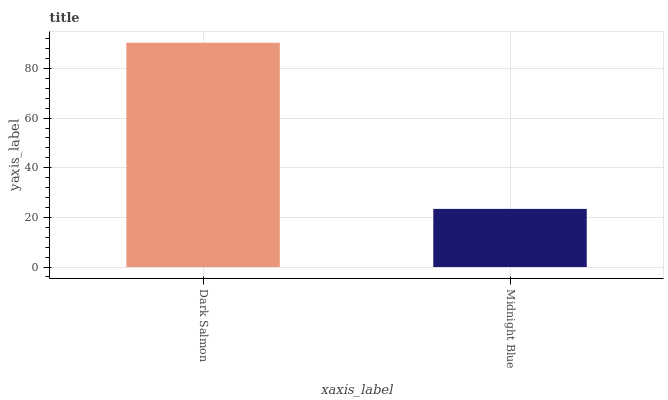Is Midnight Blue the minimum?
Answer yes or no. Yes. Is Dark Salmon the maximum?
Answer yes or no. Yes. Is Midnight Blue the maximum?
Answer yes or no. No. Is Dark Salmon greater than Midnight Blue?
Answer yes or no. Yes. Is Midnight Blue less than Dark Salmon?
Answer yes or no. Yes. Is Midnight Blue greater than Dark Salmon?
Answer yes or no. No. Is Dark Salmon less than Midnight Blue?
Answer yes or no. No. Is Dark Salmon the high median?
Answer yes or no. Yes. Is Midnight Blue the low median?
Answer yes or no. Yes. Is Midnight Blue the high median?
Answer yes or no. No. Is Dark Salmon the low median?
Answer yes or no. No. 